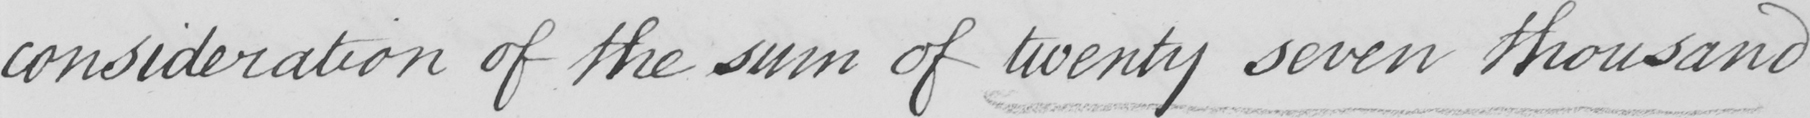What does this handwritten line say? consideration of the sum of twenty seven thousand 